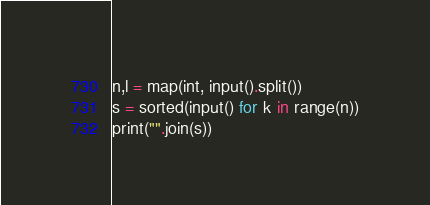<code> <loc_0><loc_0><loc_500><loc_500><_Python_>n,l = map(int, input().split())
s = sorted(input() for k in range(n))
print("".join(s))</code> 